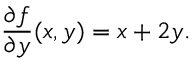<formula> <loc_0><loc_0><loc_500><loc_500>{ \frac { \partial f } { \partial y } } ( x , y ) = x + 2 y .</formula> 